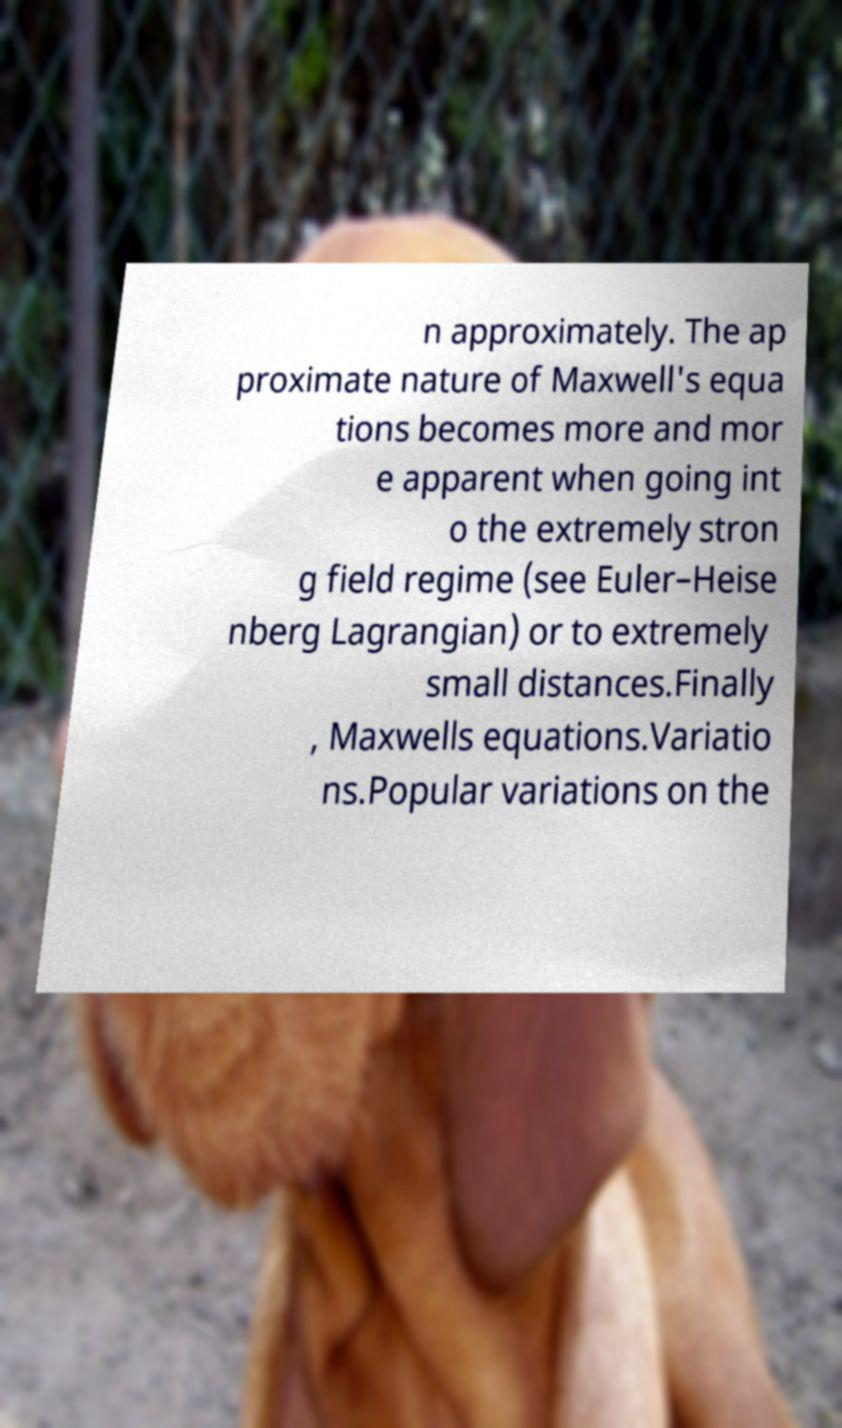There's text embedded in this image that I need extracted. Can you transcribe it verbatim? n approximately. The ap proximate nature of Maxwell's equa tions becomes more and mor e apparent when going int o the extremely stron g field regime (see Euler–Heise nberg Lagrangian) or to extremely small distances.Finally , Maxwells equations.Variatio ns.Popular variations on the 